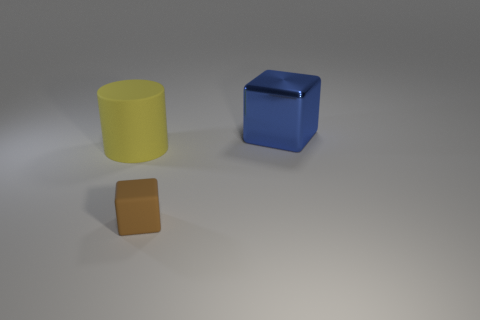Are there any other things that have the same size as the brown block?
Offer a terse response. No. The large object left of the large object on the right side of the matte cylinder is made of what material?
Ensure brevity in your answer.  Rubber. There is a thing that is both to the right of the yellow matte cylinder and in front of the shiny object; what is it made of?
Your answer should be very brief. Rubber. Is the number of matte things behind the yellow matte cylinder the same as the number of tiny yellow cubes?
Make the answer very short. Yes. What number of large metallic things have the same shape as the small brown object?
Offer a terse response. 1. There is a block in front of the cube behind the cube to the left of the big cube; what size is it?
Your response must be concise. Small. Are the big thing on the right side of the tiny brown block and the large yellow cylinder made of the same material?
Your answer should be very brief. No. Are there the same number of big yellow matte objects that are on the left side of the yellow matte cylinder and large shiny objects to the right of the blue metallic object?
Provide a short and direct response. Yes. What is the material of the other brown thing that is the same shape as the shiny thing?
Offer a very short reply. Rubber. There is a big object that is to the right of the block in front of the yellow matte cylinder; are there any tiny brown blocks that are behind it?
Offer a very short reply. No. 